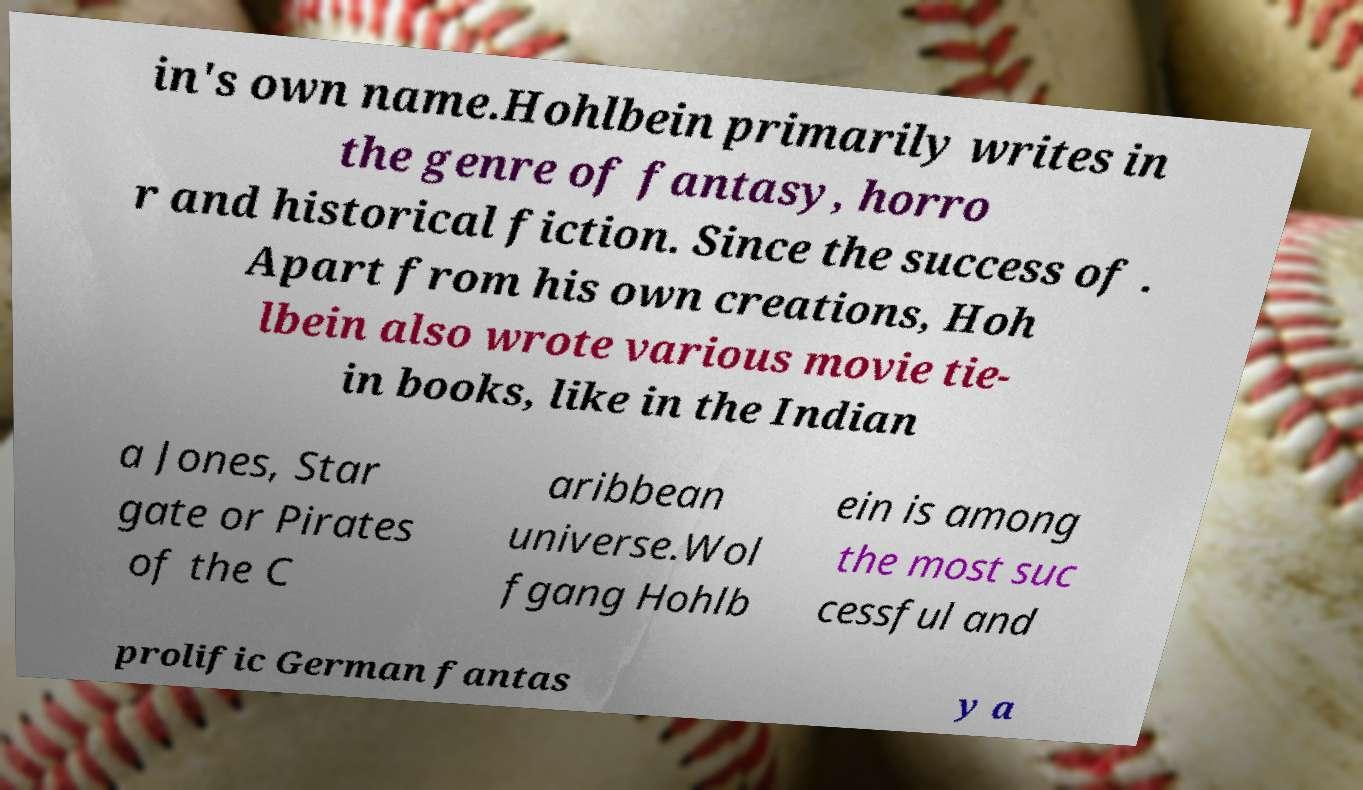Please identify and transcribe the text found in this image. in's own name.Hohlbein primarily writes in the genre of fantasy, horro r and historical fiction. Since the success of . Apart from his own creations, Hoh lbein also wrote various movie tie- in books, like in the Indian a Jones, Star gate or Pirates of the C aribbean universe.Wol fgang Hohlb ein is among the most suc cessful and prolific German fantas y a 